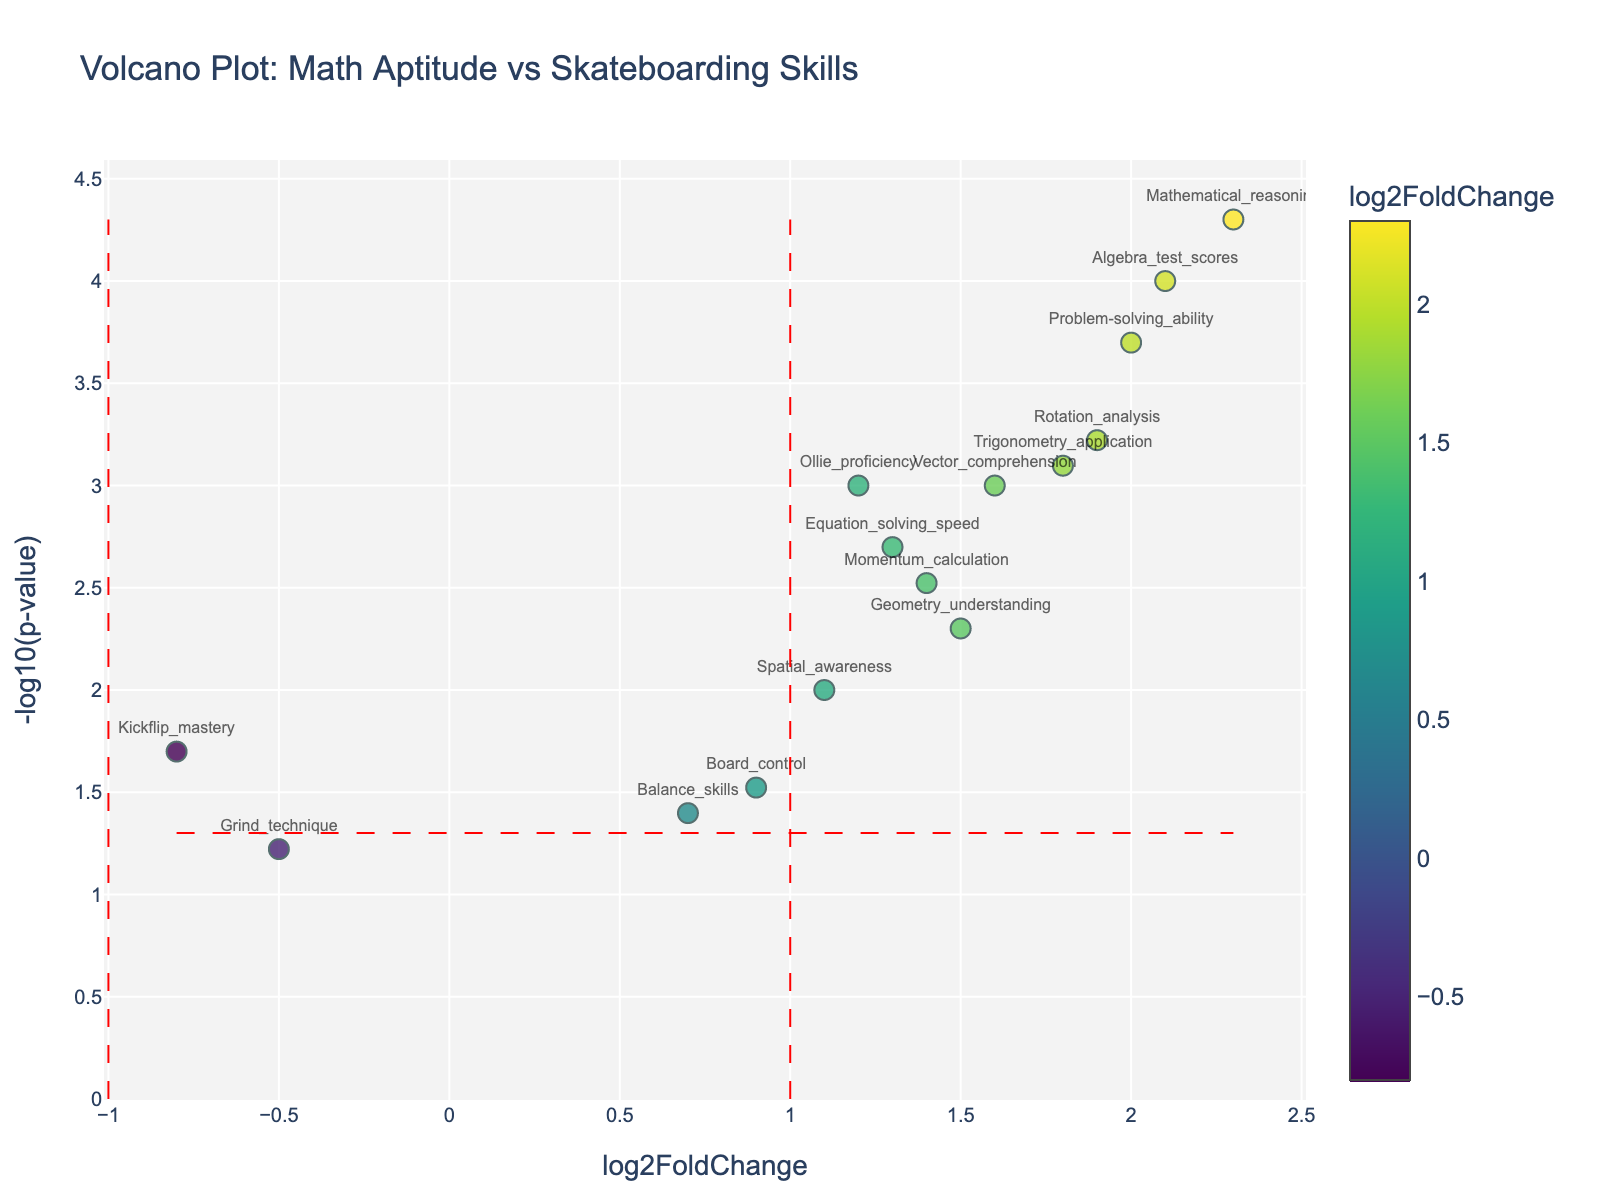Which data point has the highest -log10(p-value) and what does it represent? To find the highest -log10(p-value), look for the data point positioned at the highest y-axis value. This point is "Mathematical_reasoning".
Answer: Mathematical_reasoning What is the significance threshold for the p-value as shown by the horizontal line? Identify the y-position of the horizontal red dashed line, which represents the -log10 of the significance threshold p-value. The line is at -log10(0.05) which equals approximately 1.3.
Answer: -log10(0.05) ≈ 1.3 Which gene shows the greatest increase in correlation with math aptitude (considering positive log2FoldChange)? For the greatest increase, look for the largest positive log2FoldChange value on the x-axis. The gene "Mathematical_reasoning" has the highest value.
Answer: Mathematical_reasoning How many features are statistically significant at p<0.05 and have a log2FoldChange greater than 1? Count the data points that are above the horizontal red line (p<0.05) and also to the right of the vertical red line (log2FoldChange > 1). There are 8 such data points.
Answer: 8 Which features have a negative log2FoldChange and a p-value less than 0.05? Locate the data points to the left of the vertical red line at log2FoldChange = -1 and above the horizontal red line at -log10(0.05). Only "Kickflip_mastery" satisfies this condition.
Answer: Kickflip_mastery Compare the log2FoldChange values of "Vector_comprehension" and "Rotation_analysis". Which is higher and by how much? Find the positions of "Vector_comprehension" and "Rotation_analysis" on the x-axis. "Rotation_analysis" has a higher log2FoldChange of 1.9 compared to "Vector_comprehension" which has a value of 1.6. The difference is 1.9 - 1.6 = 0.3.
Answer: Rotation_analysis, by 0.3 What are the y-axis values for "Algebra_test_scores" and "Board_control"? Locate the vertical positions of "Algebra_test_scores" and "Board_control" on the y-axis. "Algebra_test_scores" has a -log10(p-value) of 4, and "Board_control" has a -log10(p-value) of approximately 1.52.
Answer: Algebra_test_scores: 4, Board_control: 1.52 Which feature has the smallest (most negative) log2FoldChange and what is its p-value? Look for the farthest left data point. "Kickflip_mastery" has the smallest log2FoldChange at -0.8 with a p-value of 0.02.
Answer: Kickflip_mastery, 0.02 Are there any features that have both a log2FoldChange less than -1 and are statistically significant (p < 0.05)? Check for data points to the left of the vertical red line at -1 and above the horizontal red line at -log10(0.05). There are no such points.
Answer: No 